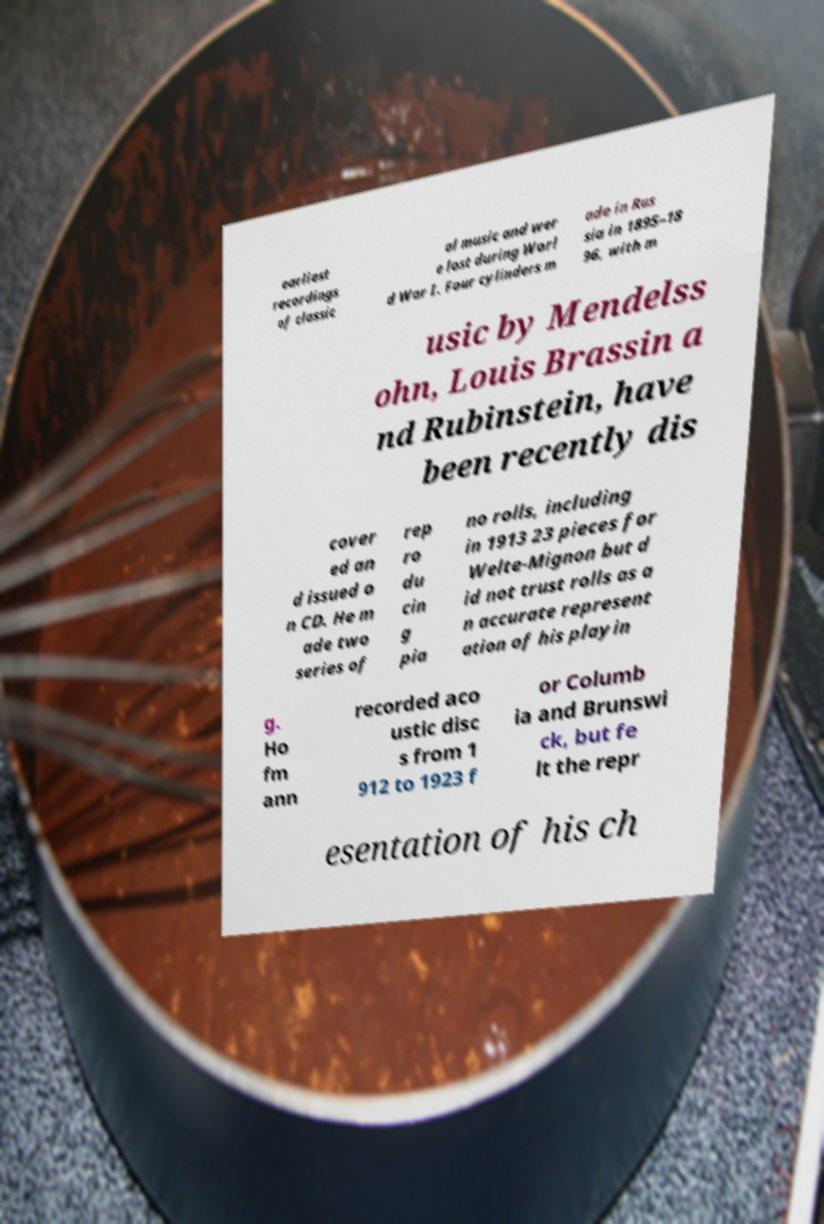There's text embedded in this image that I need extracted. Can you transcribe it verbatim? earliest recordings of classic al music and wer e lost during Worl d War I. Four cylinders m ade in Rus sia in 1895–18 96, with m usic by Mendelss ohn, Louis Brassin a nd Rubinstein, have been recently dis cover ed an d issued o n CD. He m ade two series of rep ro du cin g pia no rolls, including in 1913 23 pieces for Welte-Mignon but d id not trust rolls as a n accurate represent ation of his playin g. Ho fm ann recorded aco ustic disc s from 1 912 to 1923 f or Columb ia and Brunswi ck, but fe lt the repr esentation of his ch 